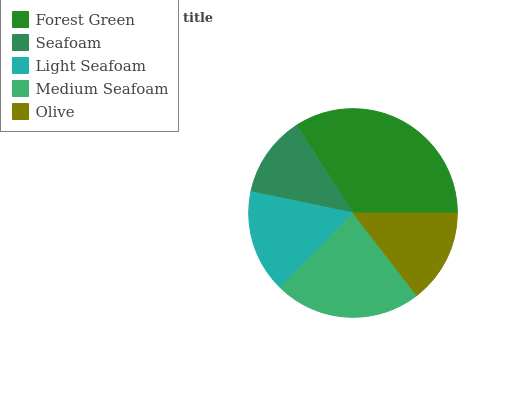Is Seafoam the minimum?
Answer yes or no. Yes. Is Forest Green the maximum?
Answer yes or no. Yes. Is Light Seafoam the minimum?
Answer yes or no. No. Is Light Seafoam the maximum?
Answer yes or no. No. Is Light Seafoam greater than Seafoam?
Answer yes or no. Yes. Is Seafoam less than Light Seafoam?
Answer yes or no. Yes. Is Seafoam greater than Light Seafoam?
Answer yes or no. No. Is Light Seafoam less than Seafoam?
Answer yes or no. No. Is Light Seafoam the high median?
Answer yes or no. Yes. Is Light Seafoam the low median?
Answer yes or no. Yes. Is Seafoam the high median?
Answer yes or no. No. Is Olive the low median?
Answer yes or no. No. 